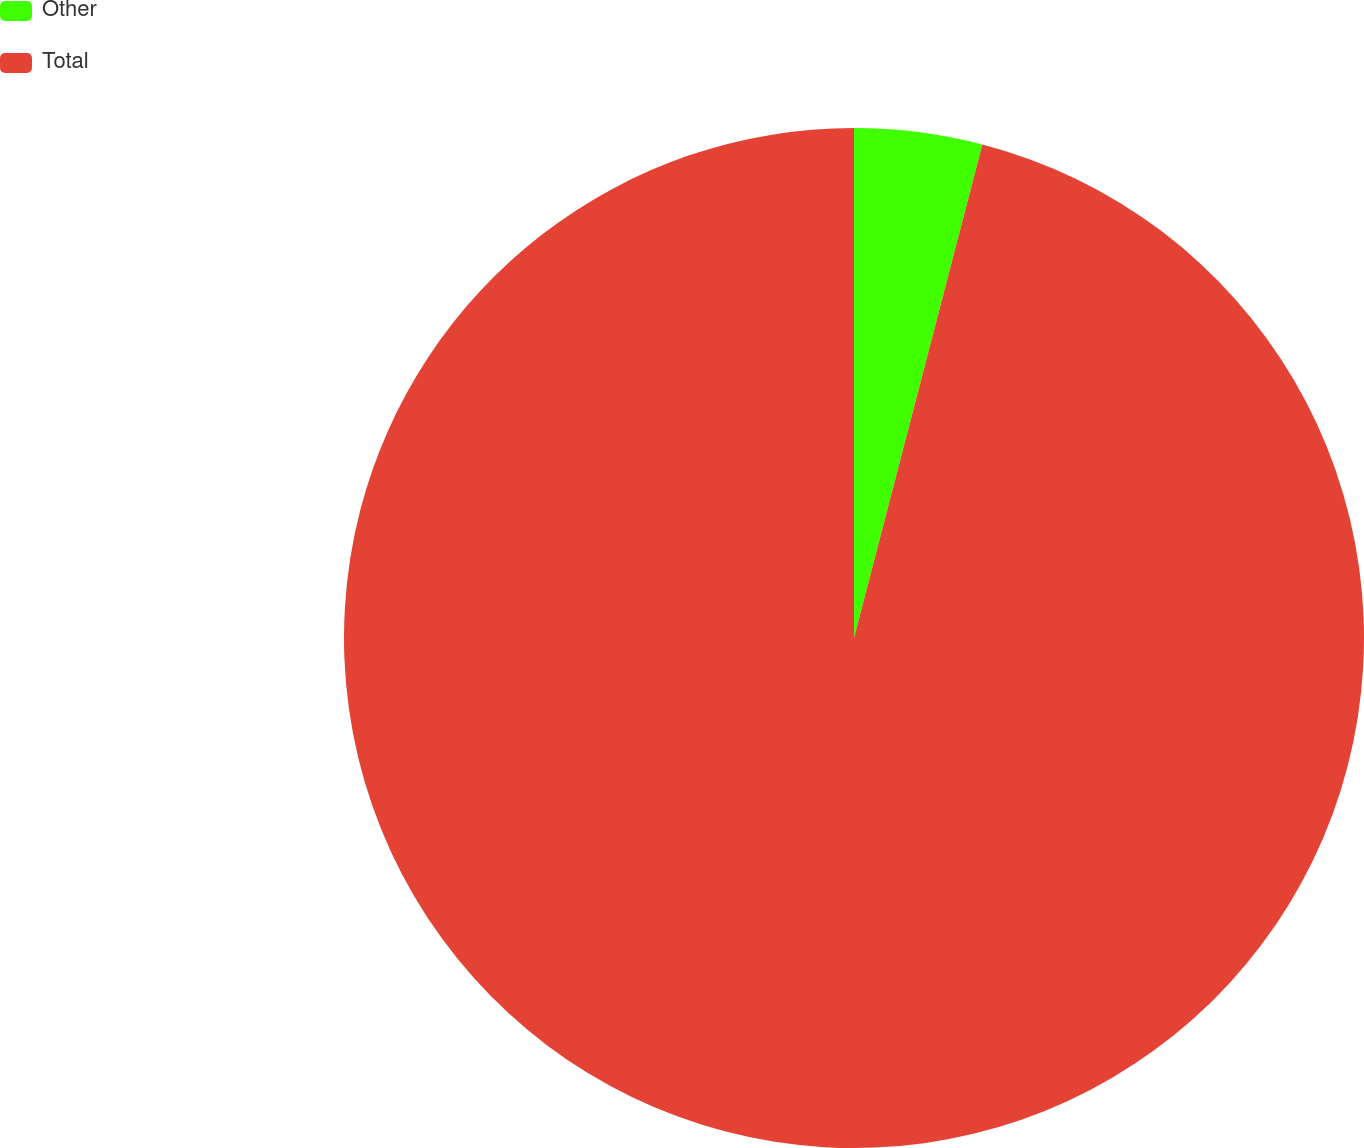Convert chart. <chart><loc_0><loc_0><loc_500><loc_500><pie_chart><fcel>Other<fcel>Total<nl><fcel>4.05%<fcel>95.95%<nl></chart> 